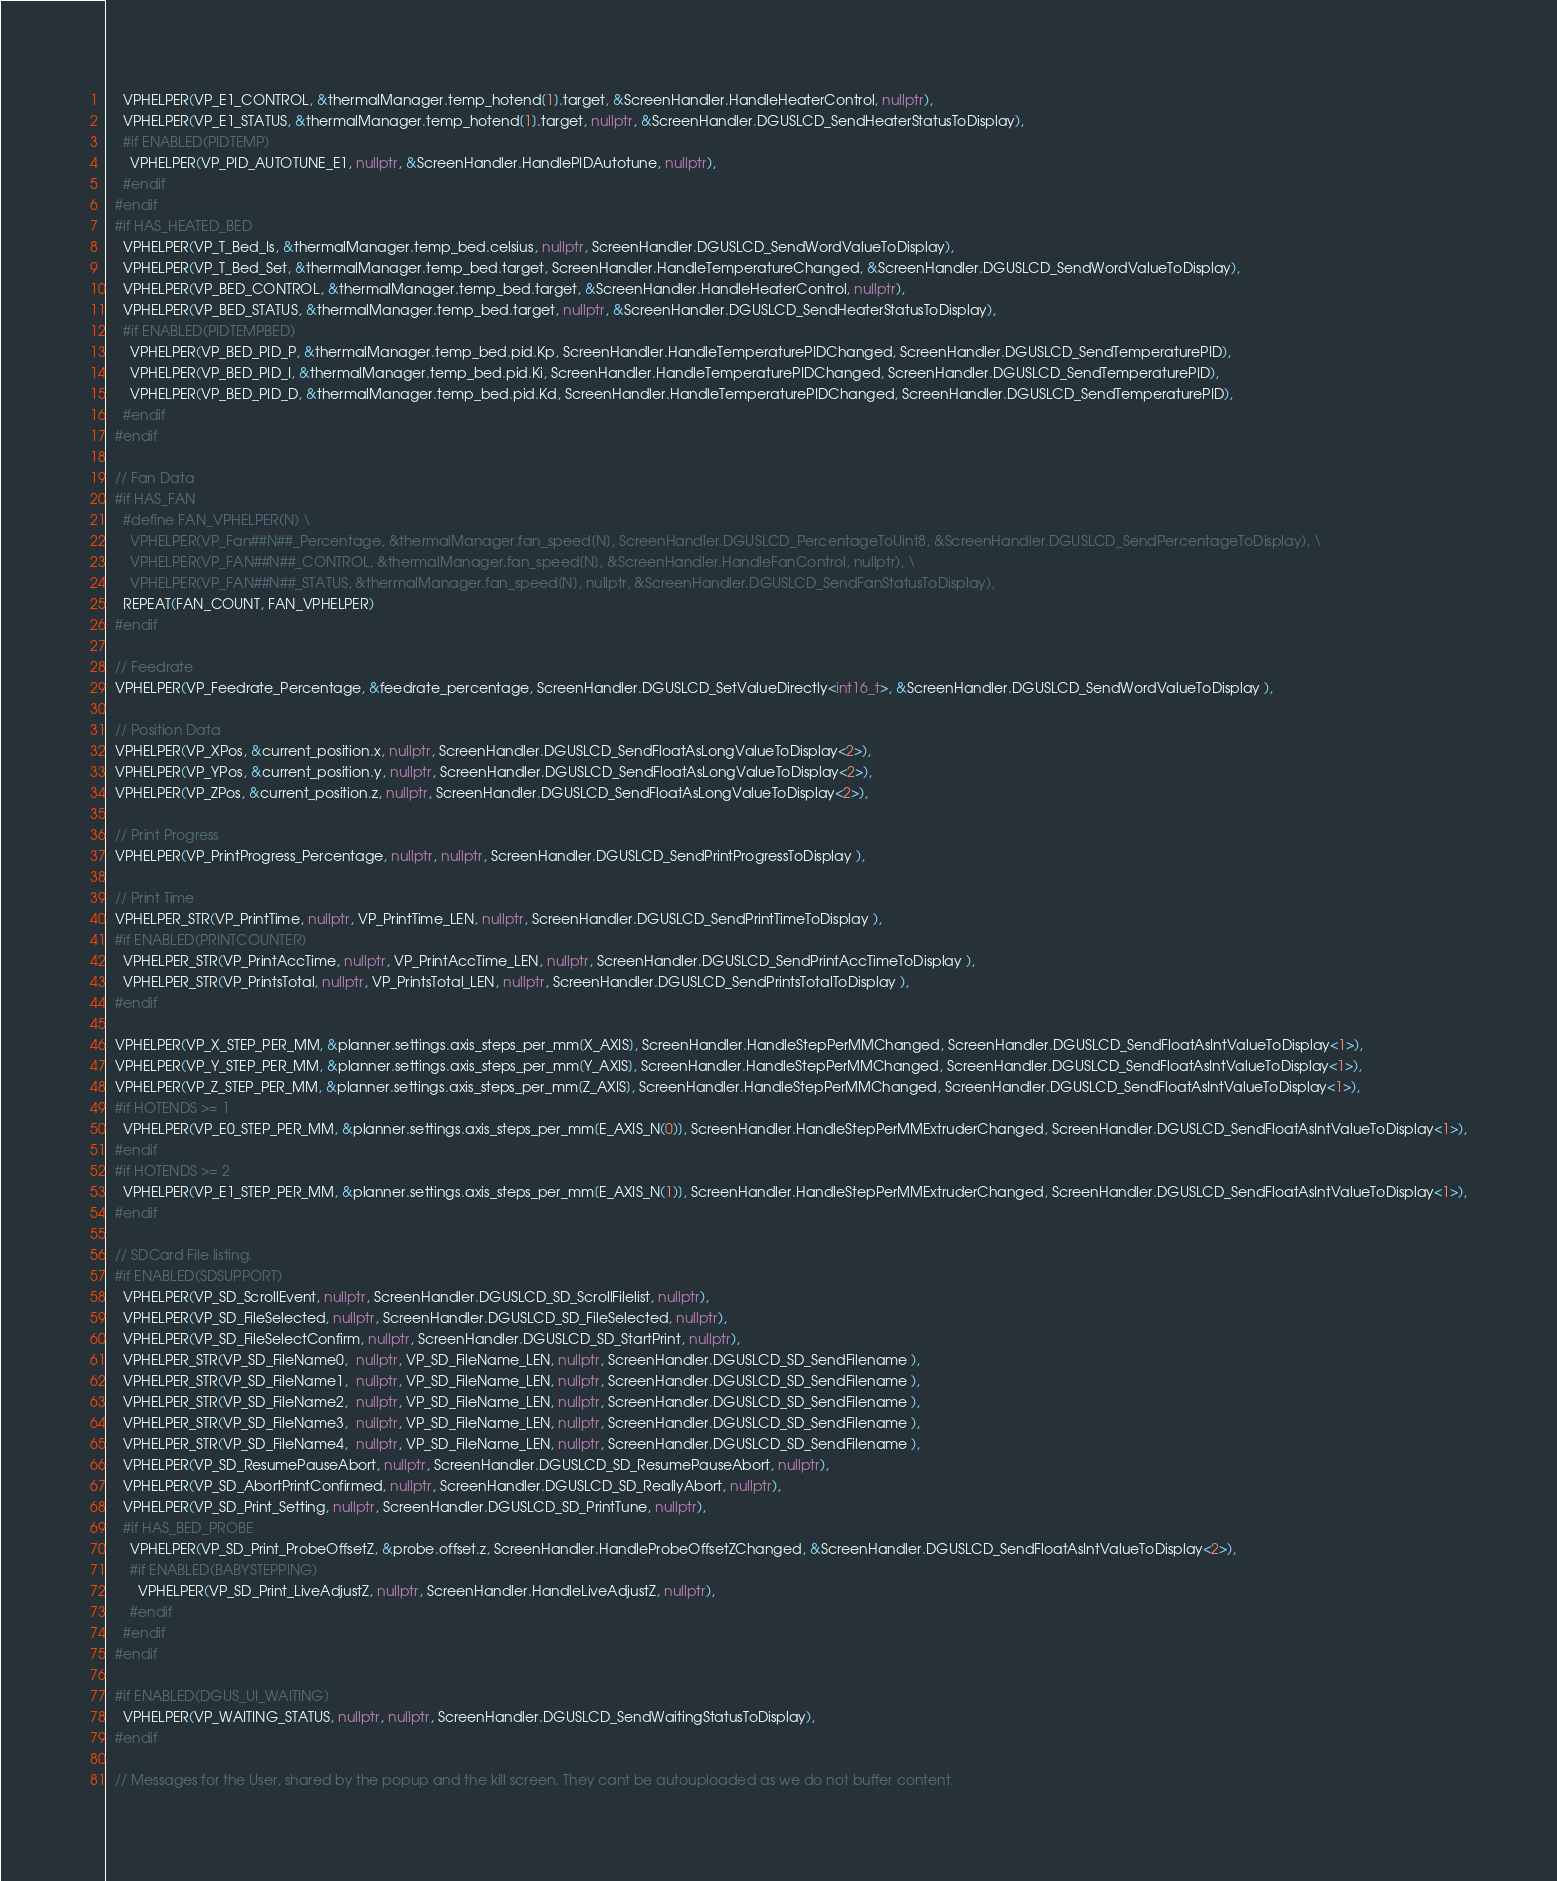<code> <loc_0><loc_0><loc_500><loc_500><_C++_>    VPHELPER(VP_E1_CONTROL, &thermalManager.temp_hotend[1].target, &ScreenHandler.HandleHeaterControl, nullptr),
    VPHELPER(VP_E1_STATUS, &thermalManager.temp_hotend[1].target, nullptr, &ScreenHandler.DGUSLCD_SendHeaterStatusToDisplay),
    #if ENABLED(PIDTEMP)
      VPHELPER(VP_PID_AUTOTUNE_E1, nullptr, &ScreenHandler.HandlePIDAutotune, nullptr),
    #endif
  #endif
  #if HAS_HEATED_BED
    VPHELPER(VP_T_Bed_Is, &thermalManager.temp_bed.celsius, nullptr, ScreenHandler.DGUSLCD_SendWordValueToDisplay),
    VPHELPER(VP_T_Bed_Set, &thermalManager.temp_bed.target, ScreenHandler.HandleTemperatureChanged, &ScreenHandler.DGUSLCD_SendWordValueToDisplay),
    VPHELPER(VP_BED_CONTROL, &thermalManager.temp_bed.target, &ScreenHandler.HandleHeaterControl, nullptr),
    VPHELPER(VP_BED_STATUS, &thermalManager.temp_bed.target, nullptr, &ScreenHandler.DGUSLCD_SendHeaterStatusToDisplay),
    #if ENABLED(PIDTEMPBED)
      VPHELPER(VP_BED_PID_P, &thermalManager.temp_bed.pid.Kp, ScreenHandler.HandleTemperaturePIDChanged, ScreenHandler.DGUSLCD_SendTemperaturePID),
      VPHELPER(VP_BED_PID_I, &thermalManager.temp_bed.pid.Ki, ScreenHandler.HandleTemperaturePIDChanged, ScreenHandler.DGUSLCD_SendTemperaturePID),
      VPHELPER(VP_BED_PID_D, &thermalManager.temp_bed.pid.Kd, ScreenHandler.HandleTemperaturePIDChanged, ScreenHandler.DGUSLCD_SendTemperaturePID),
    #endif
  #endif

  // Fan Data
  #if HAS_FAN
    #define FAN_VPHELPER(N) \
      VPHELPER(VP_Fan##N##_Percentage, &thermalManager.fan_speed[N], ScreenHandler.DGUSLCD_PercentageToUint8, &ScreenHandler.DGUSLCD_SendPercentageToDisplay), \
      VPHELPER(VP_FAN##N##_CONTROL, &thermalManager.fan_speed[N], &ScreenHandler.HandleFanControl, nullptr), \
      VPHELPER(VP_FAN##N##_STATUS, &thermalManager.fan_speed[N], nullptr, &ScreenHandler.DGUSLCD_SendFanStatusToDisplay),
    REPEAT(FAN_COUNT, FAN_VPHELPER)
  #endif

  // Feedrate
  VPHELPER(VP_Feedrate_Percentage, &feedrate_percentage, ScreenHandler.DGUSLCD_SetValueDirectly<int16_t>, &ScreenHandler.DGUSLCD_SendWordValueToDisplay ),

  // Position Data
  VPHELPER(VP_XPos, &current_position.x, nullptr, ScreenHandler.DGUSLCD_SendFloatAsLongValueToDisplay<2>),
  VPHELPER(VP_YPos, &current_position.y, nullptr, ScreenHandler.DGUSLCD_SendFloatAsLongValueToDisplay<2>),
  VPHELPER(VP_ZPos, &current_position.z, nullptr, ScreenHandler.DGUSLCD_SendFloatAsLongValueToDisplay<2>),

  // Print Progress
  VPHELPER(VP_PrintProgress_Percentage, nullptr, nullptr, ScreenHandler.DGUSLCD_SendPrintProgressToDisplay ),

  // Print Time
  VPHELPER_STR(VP_PrintTime, nullptr, VP_PrintTime_LEN, nullptr, ScreenHandler.DGUSLCD_SendPrintTimeToDisplay ),
  #if ENABLED(PRINTCOUNTER)
    VPHELPER_STR(VP_PrintAccTime, nullptr, VP_PrintAccTime_LEN, nullptr, ScreenHandler.DGUSLCD_SendPrintAccTimeToDisplay ),
    VPHELPER_STR(VP_PrintsTotal, nullptr, VP_PrintsTotal_LEN, nullptr, ScreenHandler.DGUSLCD_SendPrintsTotalToDisplay ),
  #endif

  VPHELPER(VP_X_STEP_PER_MM, &planner.settings.axis_steps_per_mm[X_AXIS], ScreenHandler.HandleStepPerMMChanged, ScreenHandler.DGUSLCD_SendFloatAsIntValueToDisplay<1>),
  VPHELPER(VP_Y_STEP_PER_MM, &planner.settings.axis_steps_per_mm[Y_AXIS], ScreenHandler.HandleStepPerMMChanged, ScreenHandler.DGUSLCD_SendFloatAsIntValueToDisplay<1>),
  VPHELPER(VP_Z_STEP_PER_MM, &planner.settings.axis_steps_per_mm[Z_AXIS], ScreenHandler.HandleStepPerMMChanged, ScreenHandler.DGUSLCD_SendFloatAsIntValueToDisplay<1>),
  #if HOTENDS >= 1
    VPHELPER(VP_E0_STEP_PER_MM, &planner.settings.axis_steps_per_mm[E_AXIS_N(0)], ScreenHandler.HandleStepPerMMExtruderChanged, ScreenHandler.DGUSLCD_SendFloatAsIntValueToDisplay<1>),
  #endif
  #if HOTENDS >= 2
    VPHELPER(VP_E1_STEP_PER_MM, &planner.settings.axis_steps_per_mm[E_AXIS_N(1)], ScreenHandler.HandleStepPerMMExtruderChanged, ScreenHandler.DGUSLCD_SendFloatAsIntValueToDisplay<1>),
  #endif

  // SDCard File listing.
  #if ENABLED(SDSUPPORT)
    VPHELPER(VP_SD_ScrollEvent, nullptr, ScreenHandler.DGUSLCD_SD_ScrollFilelist, nullptr),
    VPHELPER(VP_SD_FileSelected, nullptr, ScreenHandler.DGUSLCD_SD_FileSelected, nullptr),
    VPHELPER(VP_SD_FileSelectConfirm, nullptr, ScreenHandler.DGUSLCD_SD_StartPrint, nullptr),
    VPHELPER_STR(VP_SD_FileName0,  nullptr, VP_SD_FileName_LEN, nullptr, ScreenHandler.DGUSLCD_SD_SendFilename ),
    VPHELPER_STR(VP_SD_FileName1,  nullptr, VP_SD_FileName_LEN, nullptr, ScreenHandler.DGUSLCD_SD_SendFilename ),
    VPHELPER_STR(VP_SD_FileName2,  nullptr, VP_SD_FileName_LEN, nullptr, ScreenHandler.DGUSLCD_SD_SendFilename ),
    VPHELPER_STR(VP_SD_FileName3,  nullptr, VP_SD_FileName_LEN, nullptr, ScreenHandler.DGUSLCD_SD_SendFilename ),
    VPHELPER_STR(VP_SD_FileName4,  nullptr, VP_SD_FileName_LEN, nullptr, ScreenHandler.DGUSLCD_SD_SendFilename ),
    VPHELPER(VP_SD_ResumePauseAbort, nullptr, ScreenHandler.DGUSLCD_SD_ResumePauseAbort, nullptr),
    VPHELPER(VP_SD_AbortPrintConfirmed, nullptr, ScreenHandler.DGUSLCD_SD_ReallyAbort, nullptr),
    VPHELPER(VP_SD_Print_Setting, nullptr, ScreenHandler.DGUSLCD_SD_PrintTune, nullptr),
    #if HAS_BED_PROBE
      VPHELPER(VP_SD_Print_ProbeOffsetZ, &probe.offset.z, ScreenHandler.HandleProbeOffsetZChanged, &ScreenHandler.DGUSLCD_SendFloatAsIntValueToDisplay<2>),
      #if ENABLED(BABYSTEPPING)
        VPHELPER(VP_SD_Print_LiveAdjustZ, nullptr, ScreenHandler.HandleLiveAdjustZ, nullptr),
      #endif
    #endif
  #endif

  #if ENABLED(DGUS_UI_WAITING)
    VPHELPER(VP_WAITING_STATUS, nullptr, nullptr, ScreenHandler.DGUSLCD_SendWaitingStatusToDisplay),
  #endif

  // Messages for the User, shared by the popup and the kill screen. They cant be autouploaded as we do not buffer content.</code> 